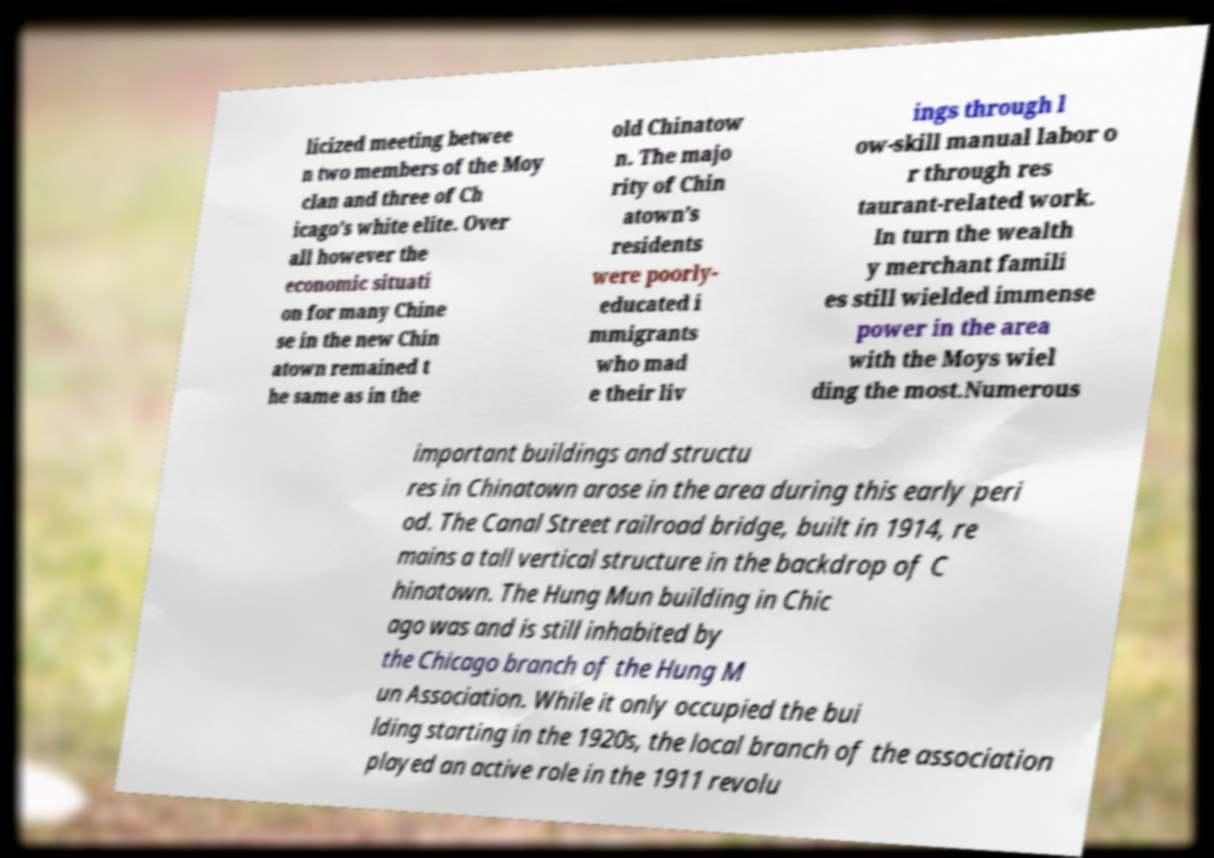Can you accurately transcribe the text from the provided image for me? licized meeting betwee n two members of the Moy clan and three of Ch icago’s white elite. Over all however the economic situati on for many Chine se in the new Chin atown remained t he same as in the old Chinatow n. The majo rity of Chin atown’s residents were poorly- educated i mmigrants who mad e their liv ings through l ow-skill manual labor o r through res taurant-related work. In turn the wealth y merchant famili es still wielded immense power in the area with the Moys wiel ding the most.Numerous important buildings and structu res in Chinatown arose in the area during this early peri od. The Canal Street railroad bridge, built in 1914, re mains a tall vertical structure in the backdrop of C hinatown. The Hung Mun building in Chic ago was and is still inhabited by the Chicago branch of the Hung M un Association. While it only occupied the bui lding starting in the 1920s, the local branch of the association played an active role in the 1911 revolu 